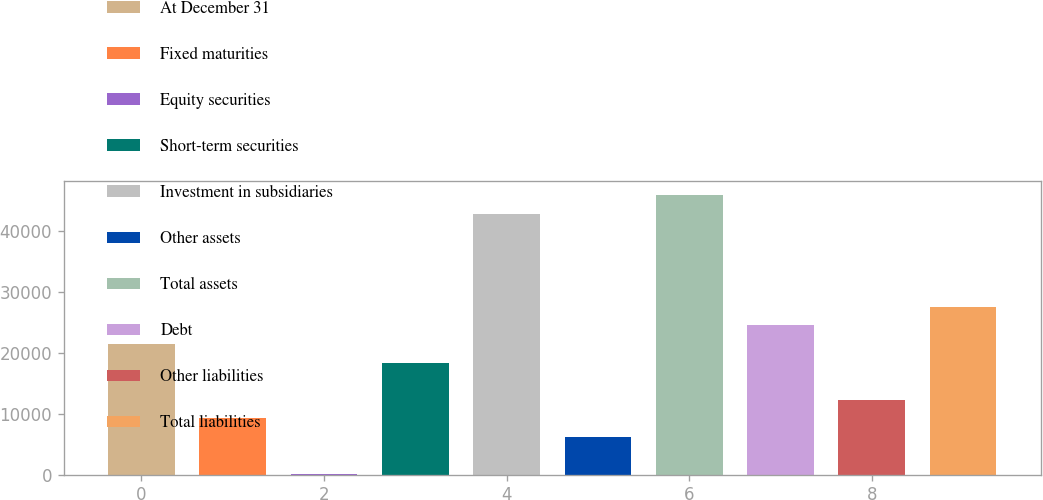Convert chart to OTSL. <chart><loc_0><loc_0><loc_500><loc_500><bar_chart><fcel>At December 31<fcel>Fixed maturities<fcel>Equity securities<fcel>Short-term securities<fcel>Investment in subsidiaries<fcel>Other assets<fcel>Total assets<fcel>Debt<fcel>Other liabilities<fcel>Total liabilities<nl><fcel>21475.9<fcel>9229.1<fcel>44<fcel>18414.2<fcel>42907.8<fcel>6167.4<fcel>45969.5<fcel>24537.6<fcel>12290.8<fcel>27599.3<nl></chart> 